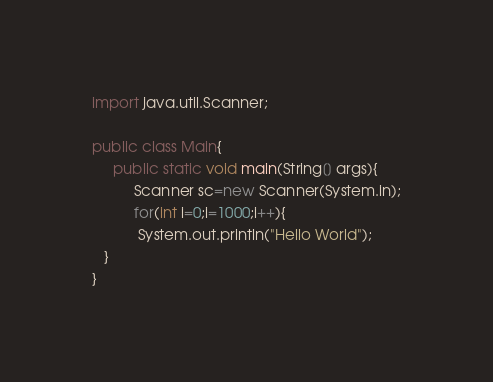Convert code to text. <code><loc_0><loc_0><loc_500><loc_500><_Java_>import java.util.Scanner;

public class Main{
     public static void main(String[] args){
          Scanner sc=new Scanner(System.in);
          for(int i=0;i=1000;i++){
           System.out.println("Hello World");
   }
}</code> 